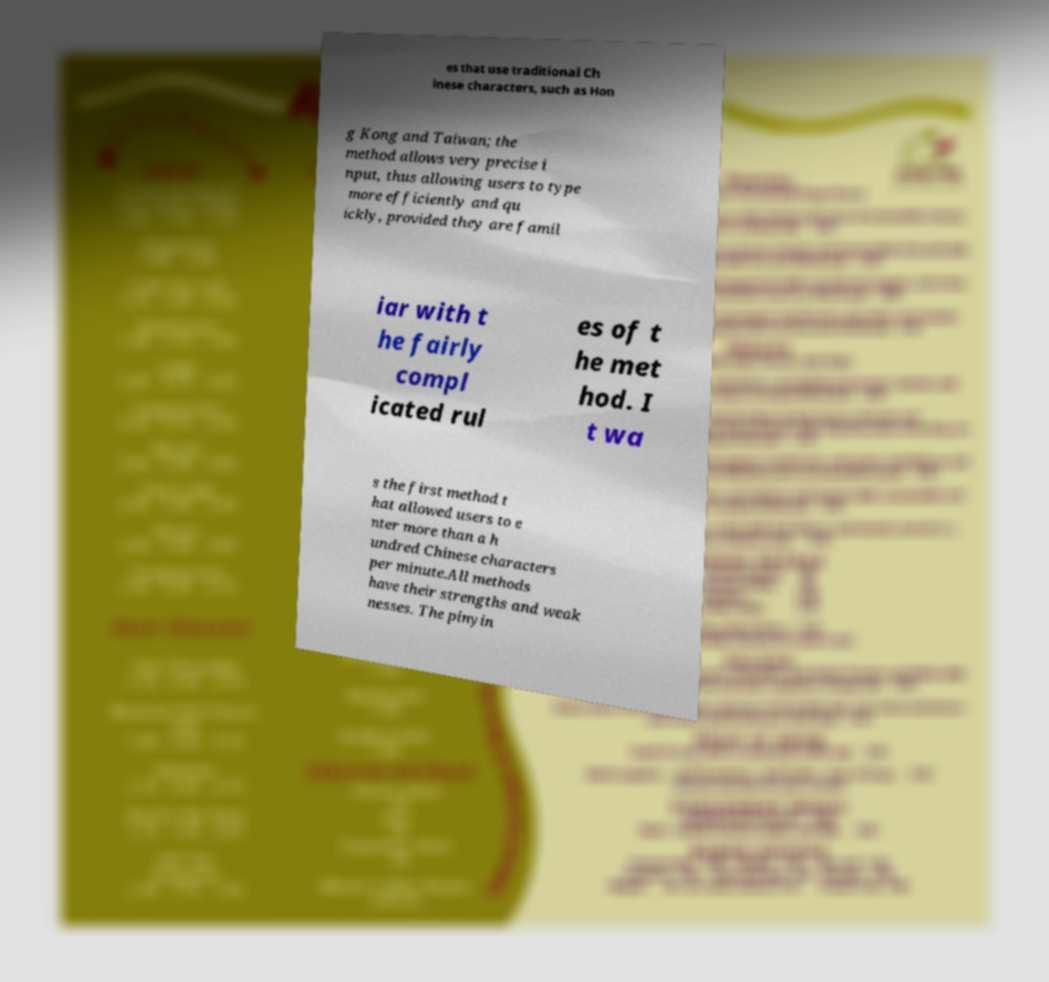Could you assist in decoding the text presented in this image and type it out clearly? es that use traditional Ch inese characters, such as Hon g Kong and Taiwan; the method allows very precise i nput, thus allowing users to type more efficiently and qu ickly, provided they are famil iar with t he fairly compl icated rul es of t he met hod. I t wa s the first method t hat allowed users to e nter more than a h undred Chinese characters per minute.All methods have their strengths and weak nesses. The pinyin 